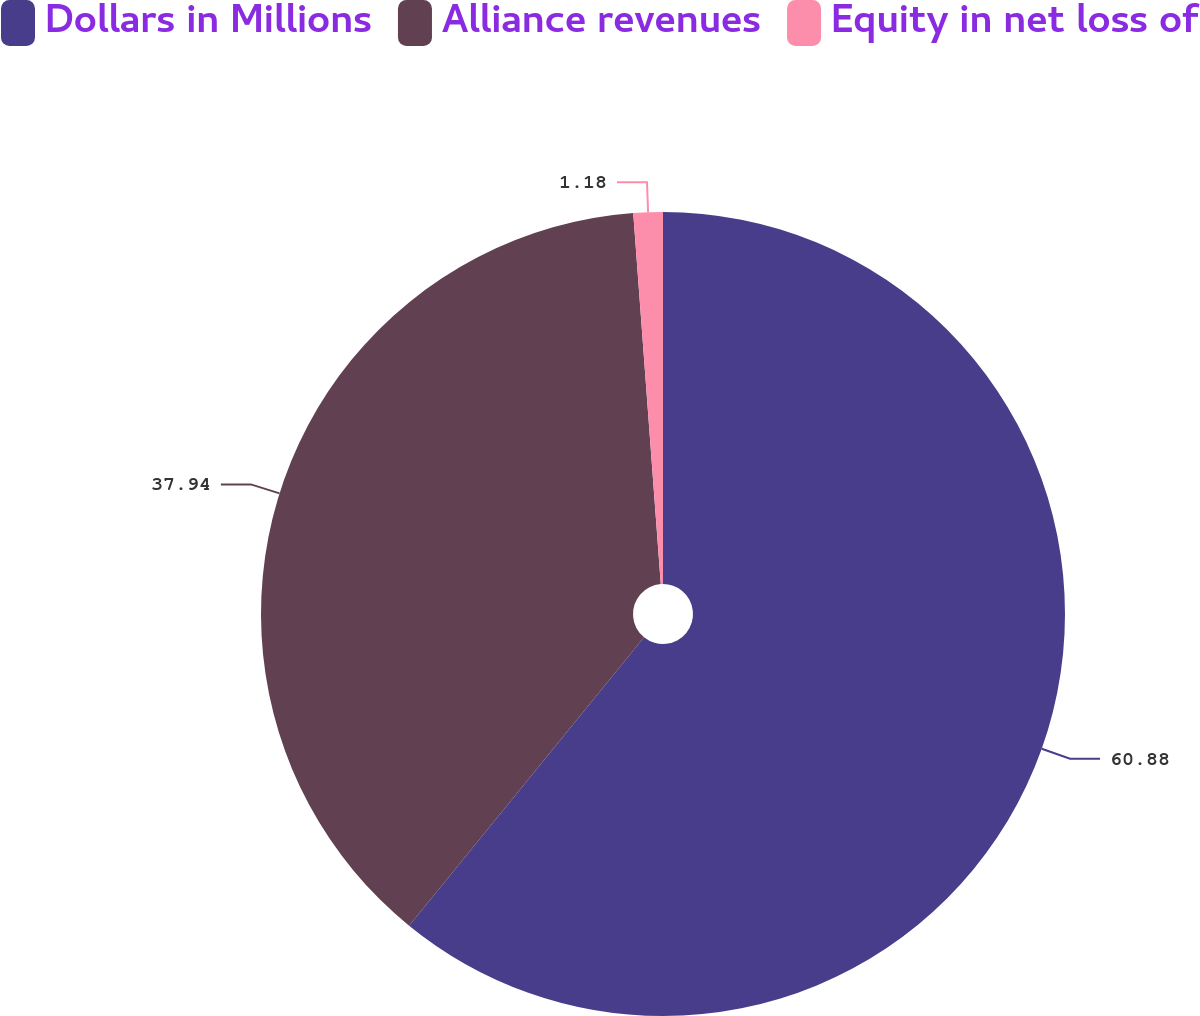<chart> <loc_0><loc_0><loc_500><loc_500><pie_chart><fcel>Dollars in Millions<fcel>Alliance revenues<fcel>Equity in net loss of<nl><fcel>60.88%<fcel>37.94%<fcel>1.18%<nl></chart> 